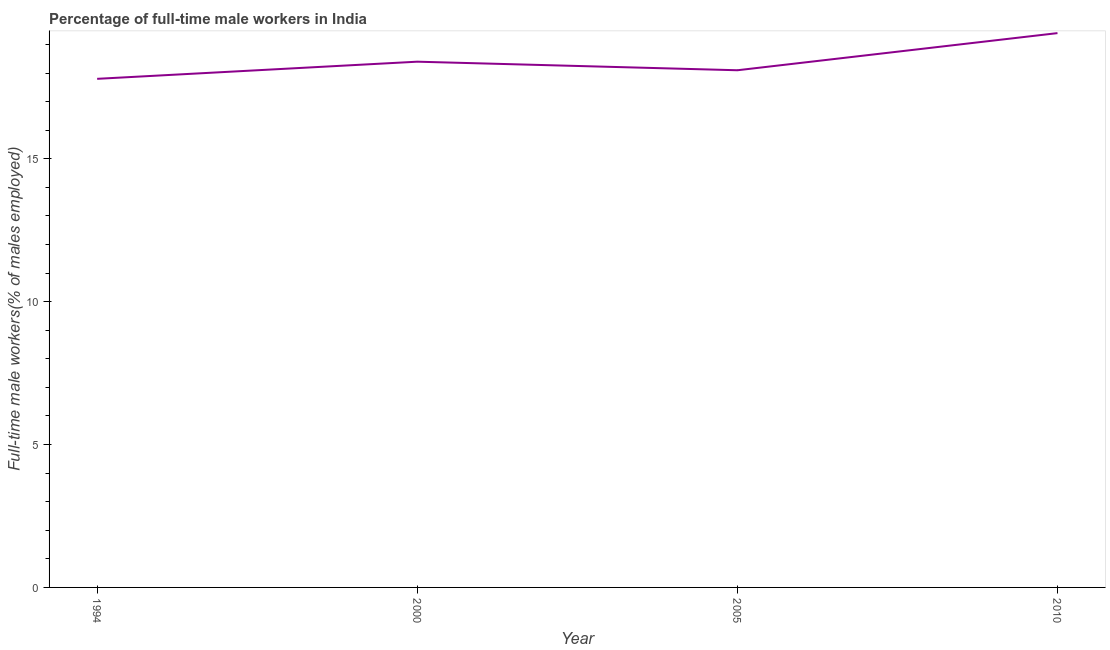What is the percentage of full-time male workers in 2005?
Make the answer very short. 18.1. Across all years, what is the maximum percentage of full-time male workers?
Provide a succinct answer. 19.4. Across all years, what is the minimum percentage of full-time male workers?
Your answer should be very brief. 17.8. In which year was the percentage of full-time male workers maximum?
Keep it short and to the point. 2010. What is the sum of the percentage of full-time male workers?
Provide a succinct answer. 73.7. What is the difference between the percentage of full-time male workers in 2005 and 2010?
Offer a very short reply. -1.3. What is the average percentage of full-time male workers per year?
Your answer should be compact. 18.42. What is the median percentage of full-time male workers?
Give a very brief answer. 18.25. What is the ratio of the percentage of full-time male workers in 2005 to that in 2010?
Offer a very short reply. 0.93. What is the difference between the highest and the lowest percentage of full-time male workers?
Your answer should be compact. 1.6. In how many years, is the percentage of full-time male workers greater than the average percentage of full-time male workers taken over all years?
Ensure brevity in your answer.  1. Does the percentage of full-time male workers monotonically increase over the years?
Keep it short and to the point. No. How many lines are there?
Make the answer very short. 1. What is the difference between two consecutive major ticks on the Y-axis?
Your response must be concise. 5. What is the title of the graph?
Give a very brief answer. Percentage of full-time male workers in India. What is the label or title of the Y-axis?
Make the answer very short. Full-time male workers(% of males employed). What is the Full-time male workers(% of males employed) in 1994?
Your response must be concise. 17.8. What is the Full-time male workers(% of males employed) of 2000?
Provide a succinct answer. 18.4. What is the Full-time male workers(% of males employed) in 2005?
Give a very brief answer. 18.1. What is the Full-time male workers(% of males employed) of 2010?
Provide a succinct answer. 19.4. What is the difference between the Full-time male workers(% of males employed) in 1994 and 2005?
Offer a very short reply. -0.3. What is the difference between the Full-time male workers(% of males employed) in 1994 and 2010?
Your response must be concise. -1.6. What is the difference between the Full-time male workers(% of males employed) in 2000 and 2005?
Your response must be concise. 0.3. What is the difference between the Full-time male workers(% of males employed) in 2000 and 2010?
Offer a very short reply. -1. What is the ratio of the Full-time male workers(% of males employed) in 1994 to that in 2000?
Keep it short and to the point. 0.97. What is the ratio of the Full-time male workers(% of males employed) in 1994 to that in 2005?
Ensure brevity in your answer.  0.98. What is the ratio of the Full-time male workers(% of males employed) in 1994 to that in 2010?
Your answer should be compact. 0.92. What is the ratio of the Full-time male workers(% of males employed) in 2000 to that in 2005?
Offer a very short reply. 1.02. What is the ratio of the Full-time male workers(% of males employed) in 2000 to that in 2010?
Your answer should be very brief. 0.95. What is the ratio of the Full-time male workers(% of males employed) in 2005 to that in 2010?
Provide a succinct answer. 0.93. 